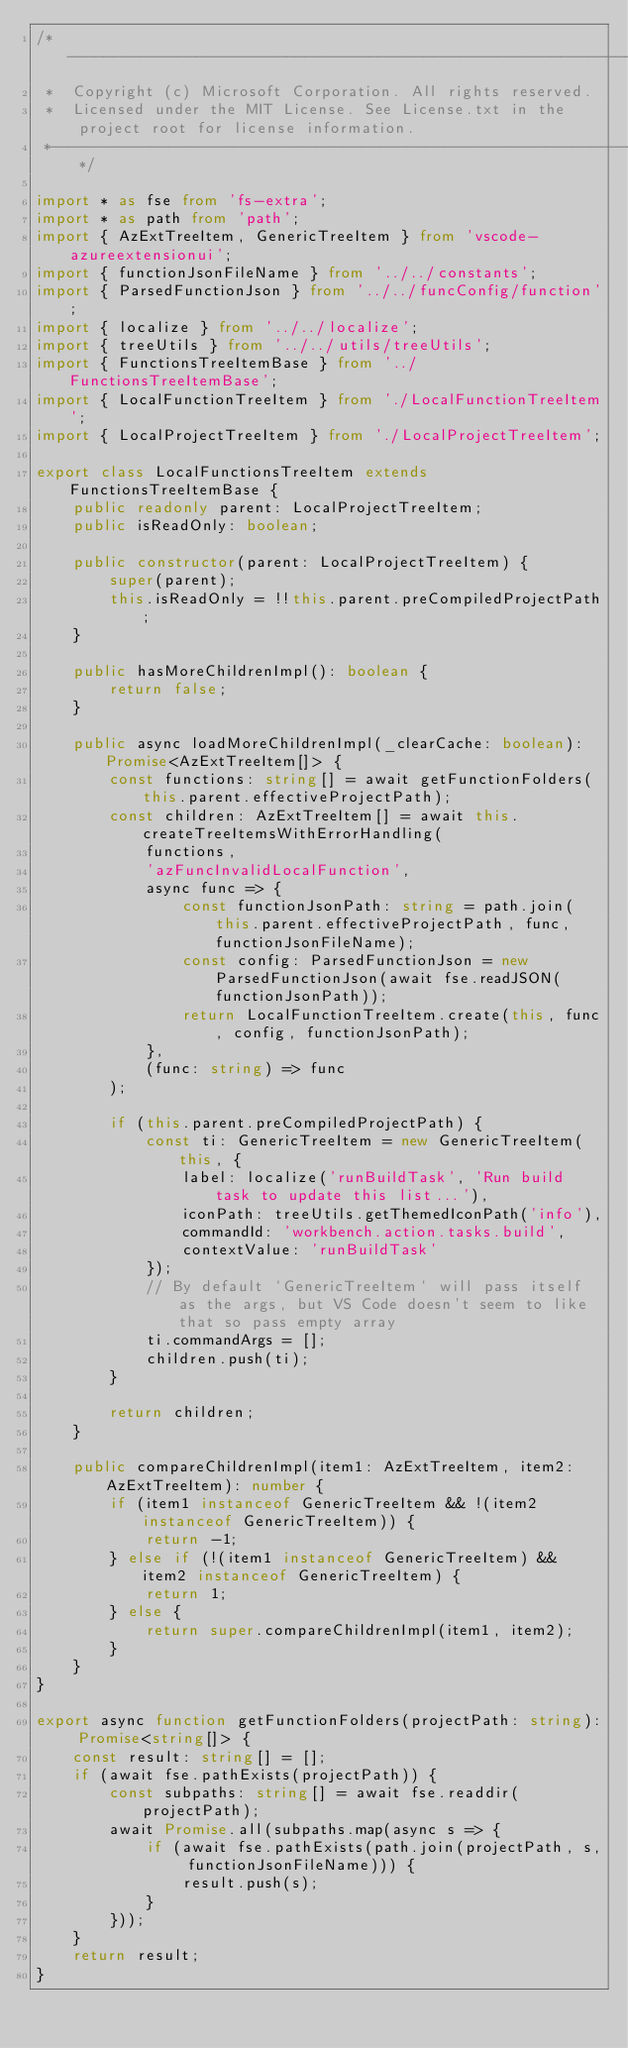<code> <loc_0><loc_0><loc_500><loc_500><_TypeScript_>/*---------------------------------------------------------------------------------------------
 *  Copyright (c) Microsoft Corporation. All rights reserved.
 *  Licensed under the MIT License. See License.txt in the project root for license information.
 *--------------------------------------------------------------------------------------------*/

import * as fse from 'fs-extra';
import * as path from 'path';
import { AzExtTreeItem, GenericTreeItem } from 'vscode-azureextensionui';
import { functionJsonFileName } from '../../constants';
import { ParsedFunctionJson } from '../../funcConfig/function';
import { localize } from '../../localize';
import { treeUtils } from '../../utils/treeUtils';
import { FunctionsTreeItemBase } from '../FunctionsTreeItemBase';
import { LocalFunctionTreeItem } from './LocalFunctionTreeItem';
import { LocalProjectTreeItem } from './LocalProjectTreeItem';

export class LocalFunctionsTreeItem extends FunctionsTreeItemBase {
    public readonly parent: LocalProjectTreeItem;
    public isReadOnly: boolean;

    public constructor(parent: LocalProjectTreeItem) {
        super(parent);
        this.isReadOnly = !!this.parent.preCompiledProjectPath;
    }

    public hasMoreChildrenImpl(): boolean {
        return false;
    }

    public async loadMoreChildrenImpl(_clearCache: boolean): Promise<AzExtTreeItem[]> {
        const functions: string[] = await getFunctionFolders(this.parent.effectiveProjectPath);
        const children: AzExtTreeItem[] = await this.createTreeItemsWithErrorHandling(
            functions,
            'azFuncInvalidLocalFunction',
            async func => {
                const functionJsonPath: string = path.join(this.parent.effectiveProjectPath, func, functionJsonFileName);
                const config: ParsedFunctionJson = new ParsedFunctionJson(await fse.readJSON(functionJsonPath));
                return LocalFunctionTreeItem.create(this, func, config, functionJsonPath);
            },
            (func: string) => func
        );

        if (this.parent.preCompiledProjectPath) {
            const ti: GenericTreeItem = new GenericTreeItem(this, {
                label: localize('runBuildTask', 'Run build task to update this list...'),
                iconPath: treeUtils.getThemedIconPath('info'),
                commandId: 'workbench.action.tasks.build',
                contextValue: 'runBuildTask'
            });
            // By default `GenericTreeItem` will pass itself as the args, but VS Code doesn't seem to like that so pass empty array
            ti.commandArgs = [];
            children.push(ti);
        }

        return children;
    }

    public compareChildrenImpl(item1: AzExtTreeItem, item2: AzExtTreeItem): number {
        if (item1 instanceof GenericTreeItem && !(item2 instanceof GenericTreeItem)) {
            return -1;
        } else if (!(item1 instanceof GenericTreeItem) && item2 instanceof GenericTreeItem) {
            return 1;
        } else {
            return super.compareChildrenImpl(item1, item2);
        }
    }
}

export async function getFunctionFolders(projectPath: string): Promise<string[]> {
    const result: string[] = [];
    if (await fse.pathExists(projectPath)) {
        const subpaths: string[] = await fse.readdir(projectPath);
        await Promise.all(subpaths.map(async s => {
            if (await fse.pathExists(path.join(projectPath, s, functionJsonFileName))) {
                result.push(s);
            }
        }));
    }
    return result;
}
</code> 